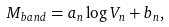<formula> <loc_0><loc_0><loc_500><loc_500>M _ { b a n d } = a _ { n } \log V _ { n } + b _ { n } ,</formula> 